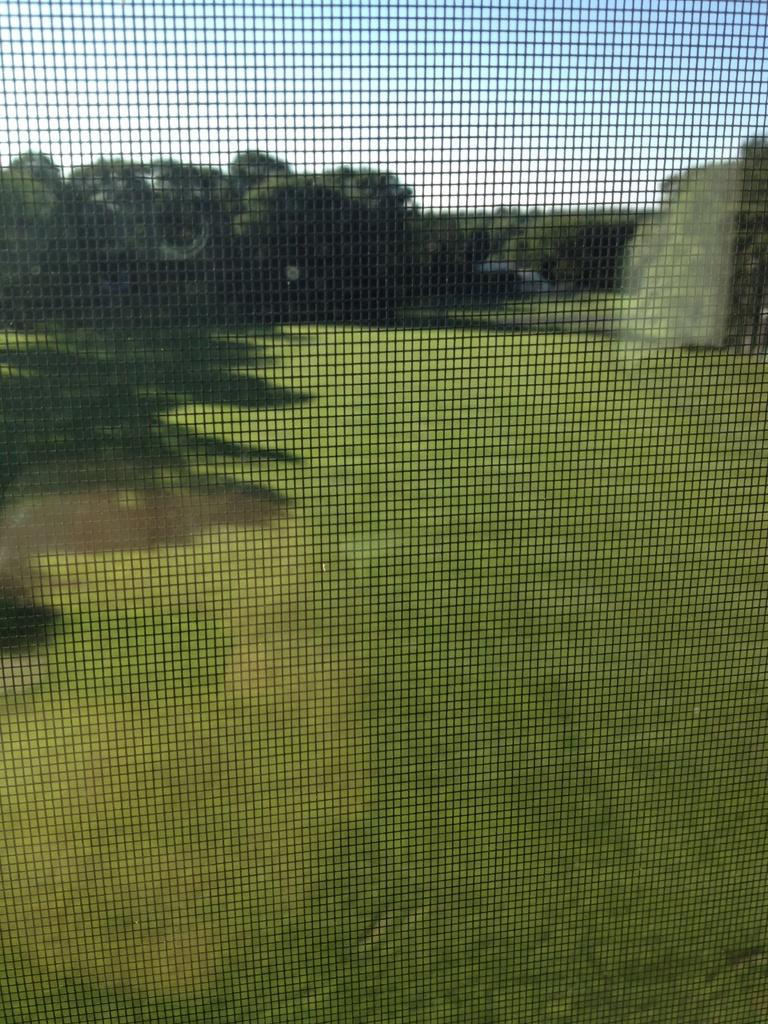What is located in the forefront of the image? There is a net in the forefront of the image. What can be seen through the net? Trees are visible through the net. What type of vegetation is present on the ground? Grass is present on the ground. What is visible in the sky? There are clouds in the sky. Where is the hat placed in the image? There is no hat present in the image. Can you describe the cart in the image? There is no cart present in the image. 